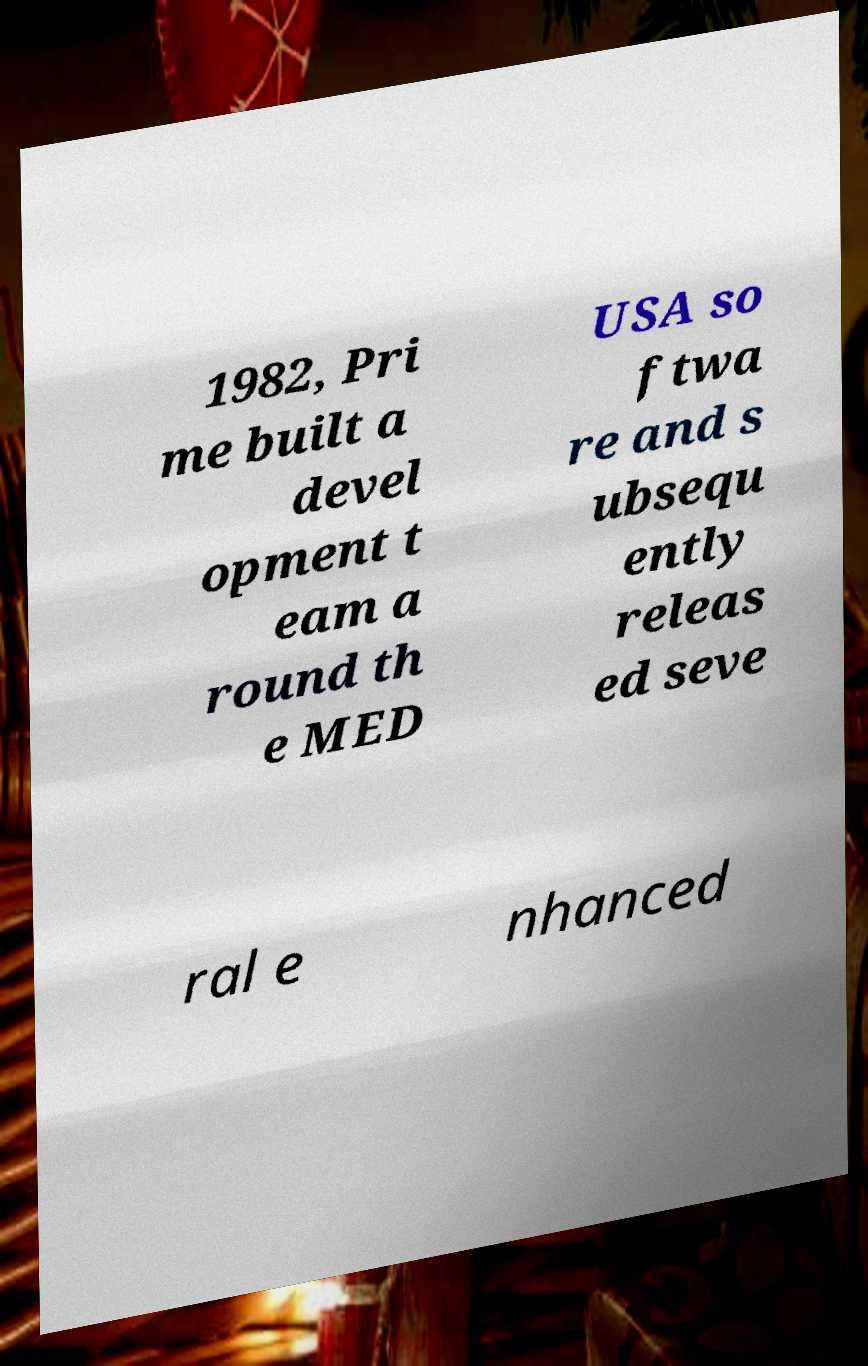Please read and relay the text visible in this image. What does it say? 1982, Pri me built a devel opment t eam a round th e MED USA so ftwa re and s ubsequ ently releas ed seve ral e nhanced 